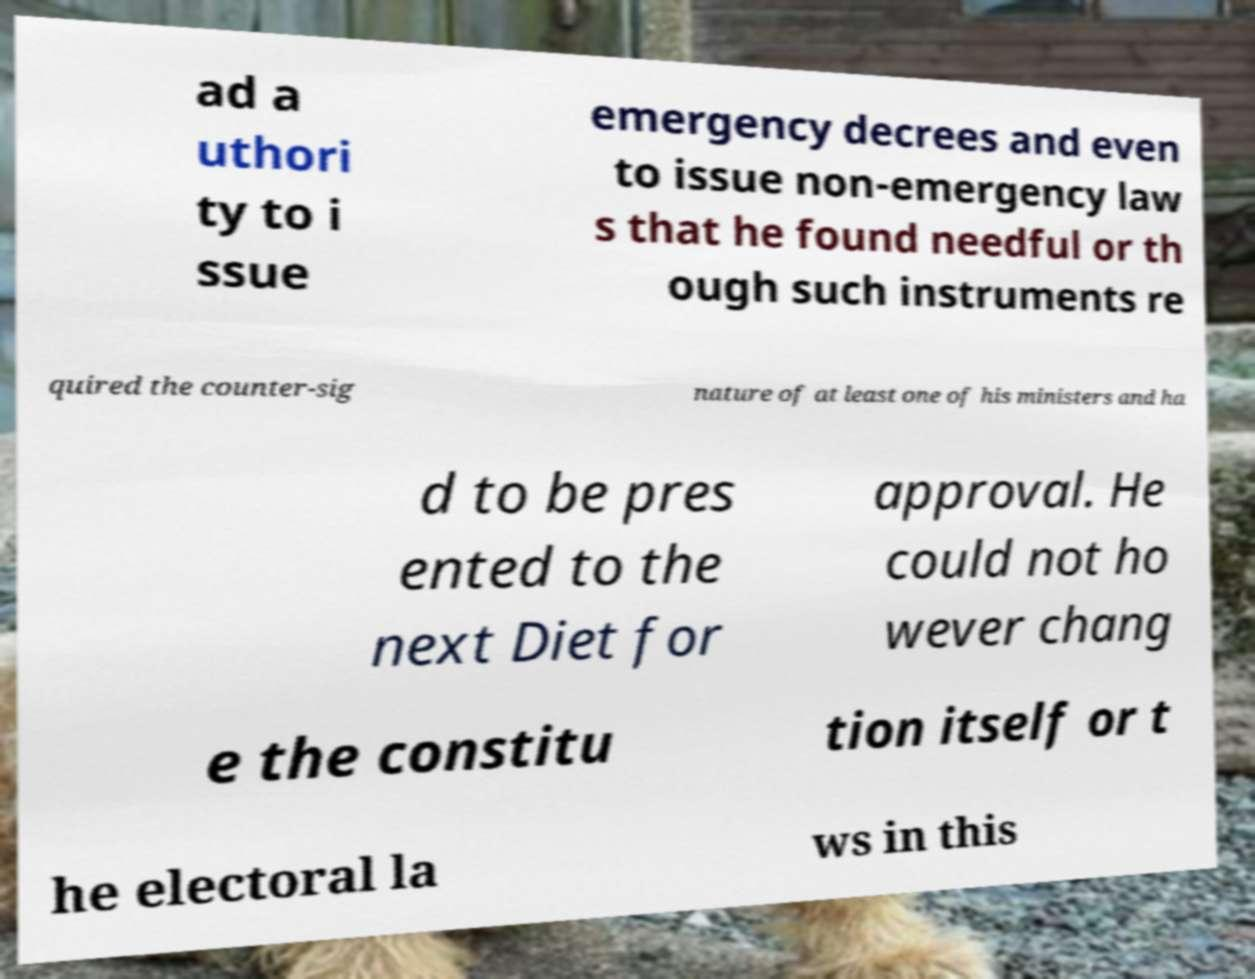Could you extract and type out the text from this image? ad a uthori ty to i ssue emergency decrees and even to issue non-emergency law s that he found needful or th ough such instruments re quired the counter-sig nature of at least one of his ministers and ha d to be pres ented to the next Diet for approval. He could not ho wever chang e the constitu tion itself or t he electoral la ws in this 